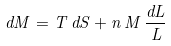Convert formula to latex. <formula><loc_0><loc_0><loc_500><loc_500>d M = T \, d S + n \, M \, \frac { d L } { L }</formula> 